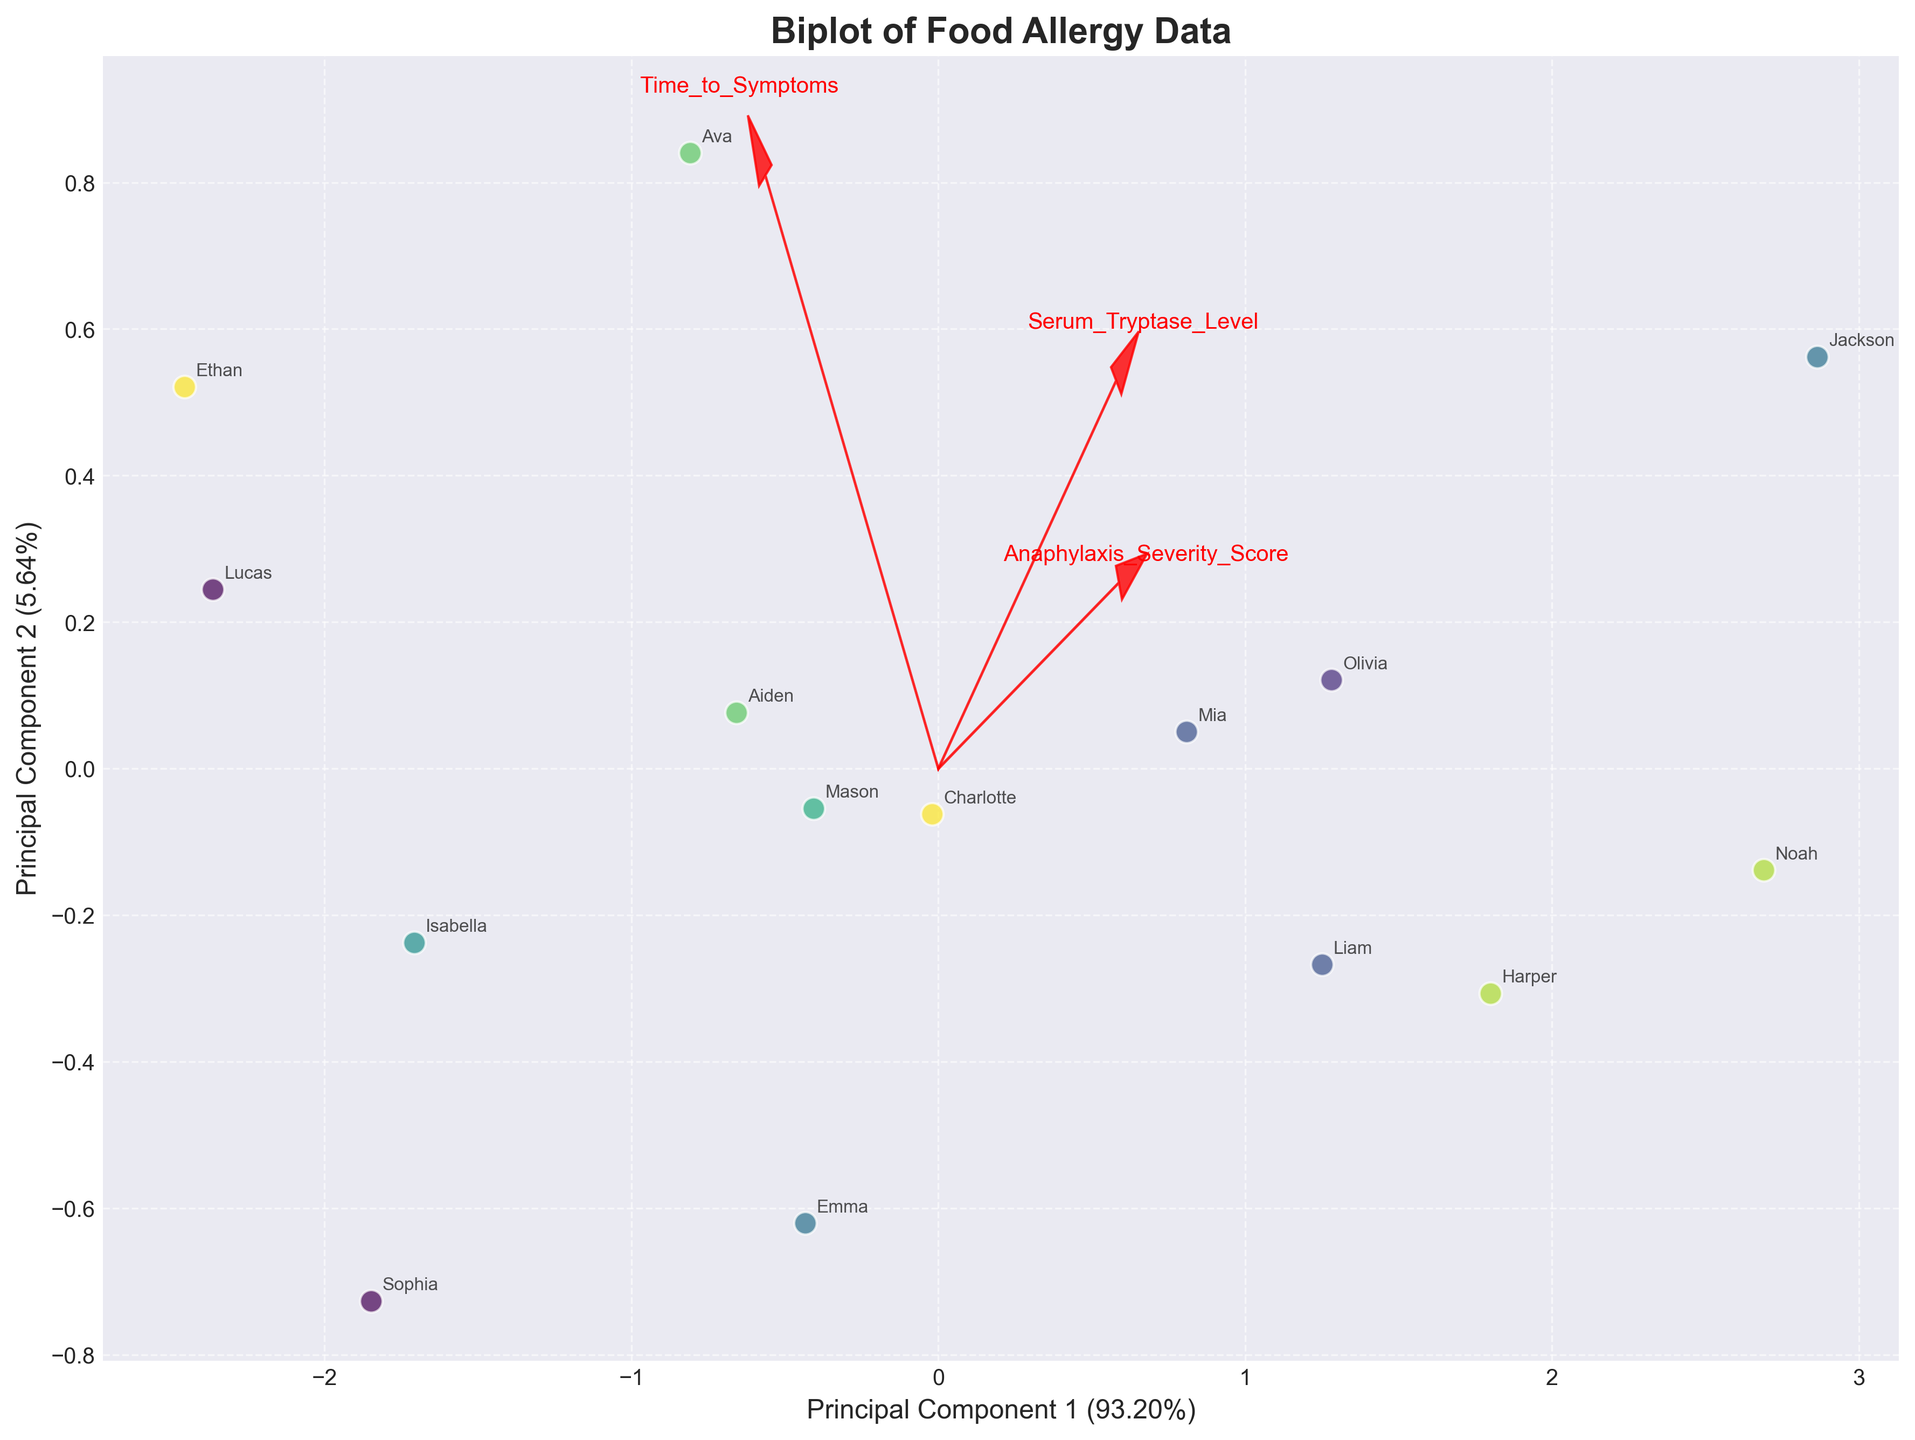what is the title of this plot? The title is displayed prominently at the top of the figure.
Answer: Biplot of Food Allergy Data How many principal components are shown? Two principal components are shown along the axes labeled Principal Component 1 and Principal Component 2.
Answer: Two What allergens are represented in the plot? The allergens are displayed in the legend on the right side of the plot.
Answer: Peanut, Milk, Egg, Tree_Nuts, Soy, Wheat, Fish, Shellfish, Sesame Which patient has the highest Anaphylaxis Severity Score? By looking at the labeled data points, the patient with the highest y-coordinate in Principal Component 2 is Jackson, who has an Anaphylaxis Severity Score of 5.
Answer: Jackson How are the Serum Tryptase Level and Time to Symptoms related to Principal Component 1? The arrows representing Serum Tryptase Level and Time to Symptoms indicate their contribution to Principal Component 1. The length and direction of these arrows show that Serum Tryptase Level has a strong positive relationship, while Time to Symptoms has a negative relationship with Principal Component 1.
Answer: Serum Tryptase Level is positively related; Time to Symptoms is negatively related Which variables contribute most strongly to Principal Component 2? By examining the arrows, Anaphylaxis Severity Score has a clear, strong vector pointing along Principal Component 2, indicating it is the primary contributor.
Answer: Anaphylaxis Severity Score What is the general distribution pattern of Soy-allergic patients in the biplot? The Patient scatter plot reveals that Soy-allergic patients (Ava and Aiden) are clustered in the middle and towards the lower part of Principal Component 1 and Principal Component 2.
Answer: Middle-lower Do Milk-allergic patients have higher Serum Tryptase Levels compared to Egg-allergic patients? Comparing the positions of Milk and Egg allergen points and the direction of the Serum Tryptase Level arrow, Milk-allergic patients (Liam and Mia) are shifted more positively along the axis associated with higher serum tryptase.
Answer: Yes Which allergen group is most spread out in the plot? Visual inspection shows the Tree_Nuts group (Noah and Harper) has points that are furthest apart on the biplot.
Answer: Tree_Nuts 